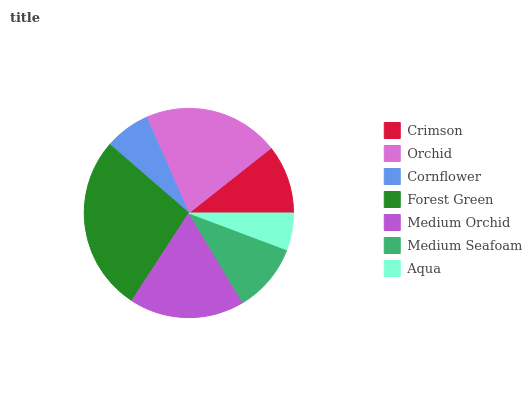Is Aqua the minimum?
Answer yes or no. Yes. Is Forest Green the maximum?
Answer yes or no. Yes. Is Orchid the minimum?
Answer yes or no. No. Is Orchid the maximum?
Answer yes or no. No. Is Orchid greater than Crimson?
Answer yes or no. Yes. Is Crimson less than Orchid?
Answer yes or no. Yes. Is Crimson greater than Orchid?
Answer yes or no. No. Is Orchid less than Crimson?
Answer yes or no. No. Is Medium Seafoam the high median?
Answer yes or no. Yes. Is Medium Seafoam the low median?
Answer yes or no. Yes. Is Forest Green the high median?
Answer yes or no. No. Is Medium Orchid the low median?
Answer yes or no. No. 